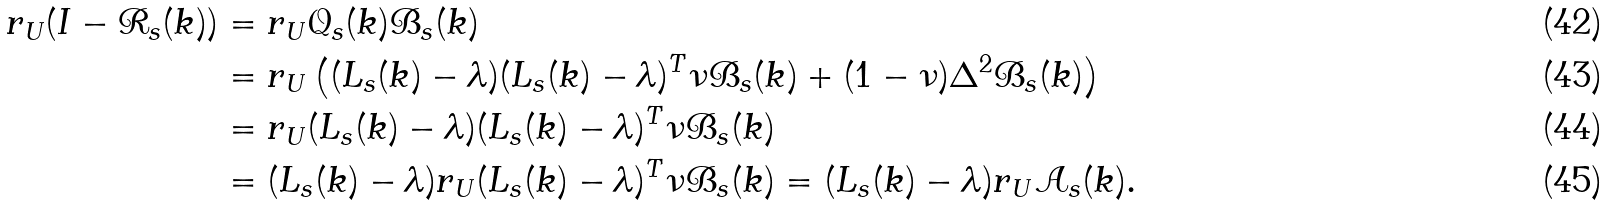Convert formula to latex. <formula><loc_0><loc_0><loc_500><loc_500>r _ { U } ( I - \mathcal { R } _ { s } ( k ) ) & = r _ { U } \mathcal { Q } _ { s } ( k ) \mathcal { B } _ { s } ( k ) \\ & = r _ { U } \left ( ( L _ { s } ( k ) - \lambda ) ( L _ { s } ( k ) - \lambda ) ^ { T } \nu \mathcal { B } _ { s } ( k ) + ( 1 - \nu ) \Delta ^ { 2 } \mathcal { B } _ { s } ( k ) \right ) \\ & = r _ { U } ( L _ { s } ( k ) - \lambda ) ( L _ { s } ( k ) - \lambda ) ^ { T } \nu \mathcal { B } _ { s } ( k ) \\ & = ( L _ { s } ( k ) - \lambda ) r _ { U } ( L _ { s } ( k ) - \lambda ) ^ { T } \nu \mathcal { B } _ { s } ( k ) = ( L _ { s } ( k ) - \lambda ) r _ { U } \mathcal { A } _ { s } ( k ) .</formula> 